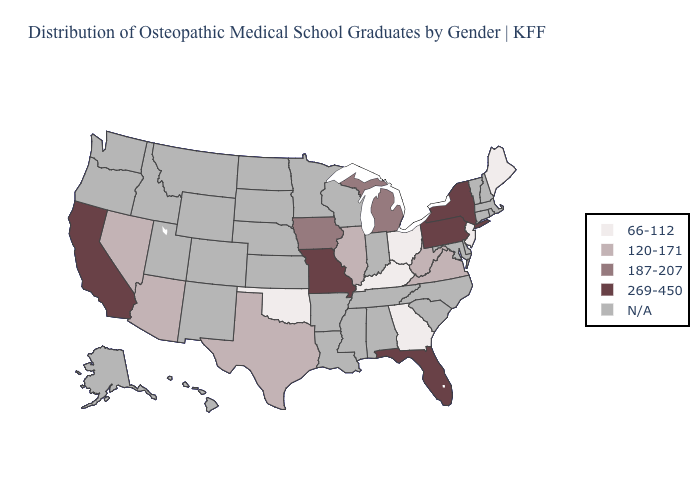What is the value of Oklahoma?
Quick response, please. 66-112. Does Florida have the highest value in the USA?
Short answer required. Yes. Is the legend a continuous bar?
Quick response, please. No. What is the lowest value in states that border Florida?
Concise answer only. 66-112. What is the value of Ohio?
Keep it brief. 66-112. Name the states that have a value in the range 269-450?
Short answer required. California, Florida, Missouri, New York, Pennsylvania. What is the value of Rhode Island?
Give a very brief answer. N/A. What is the highest value in the MidWest ?
Quick response, please. 269-450. Does Florida have the lowest value in the USA?
Answer briefly. No. What is the value of New Mexico?
Quick response, please. N/A. Is the legend a continuous bar?
Answer briefly. No. What is the lowest value in the South?
Give a very brief answer. 66-112. 